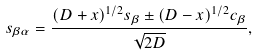<formula> <loc_0><loc_0><loc_500><loc_500>s _ { \beta \alpha } = \frac { ( D + x ) ^ { 1 / 2 } s _ { \beta } \pm ( D - x ) ^ { 1 / 2 } c _ { \beta } } { \sqrt { 2 D } } ,</formula> 